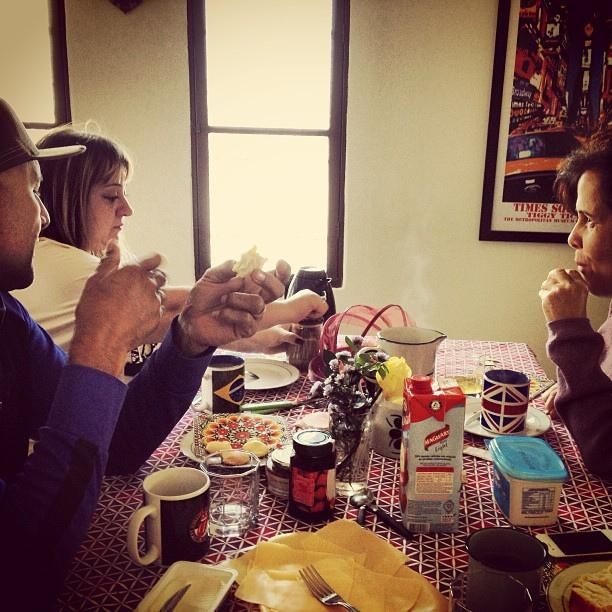Why have these people gathered? to eat 